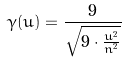<formula> <loc_0><loc_0><loc_500><loc_500>\gamma ( u ) = \frac { 9 } { \sqrt { 9 \cdot \frac { u ^ { 2 } } { n ^ { 2 } } } }</formula> 